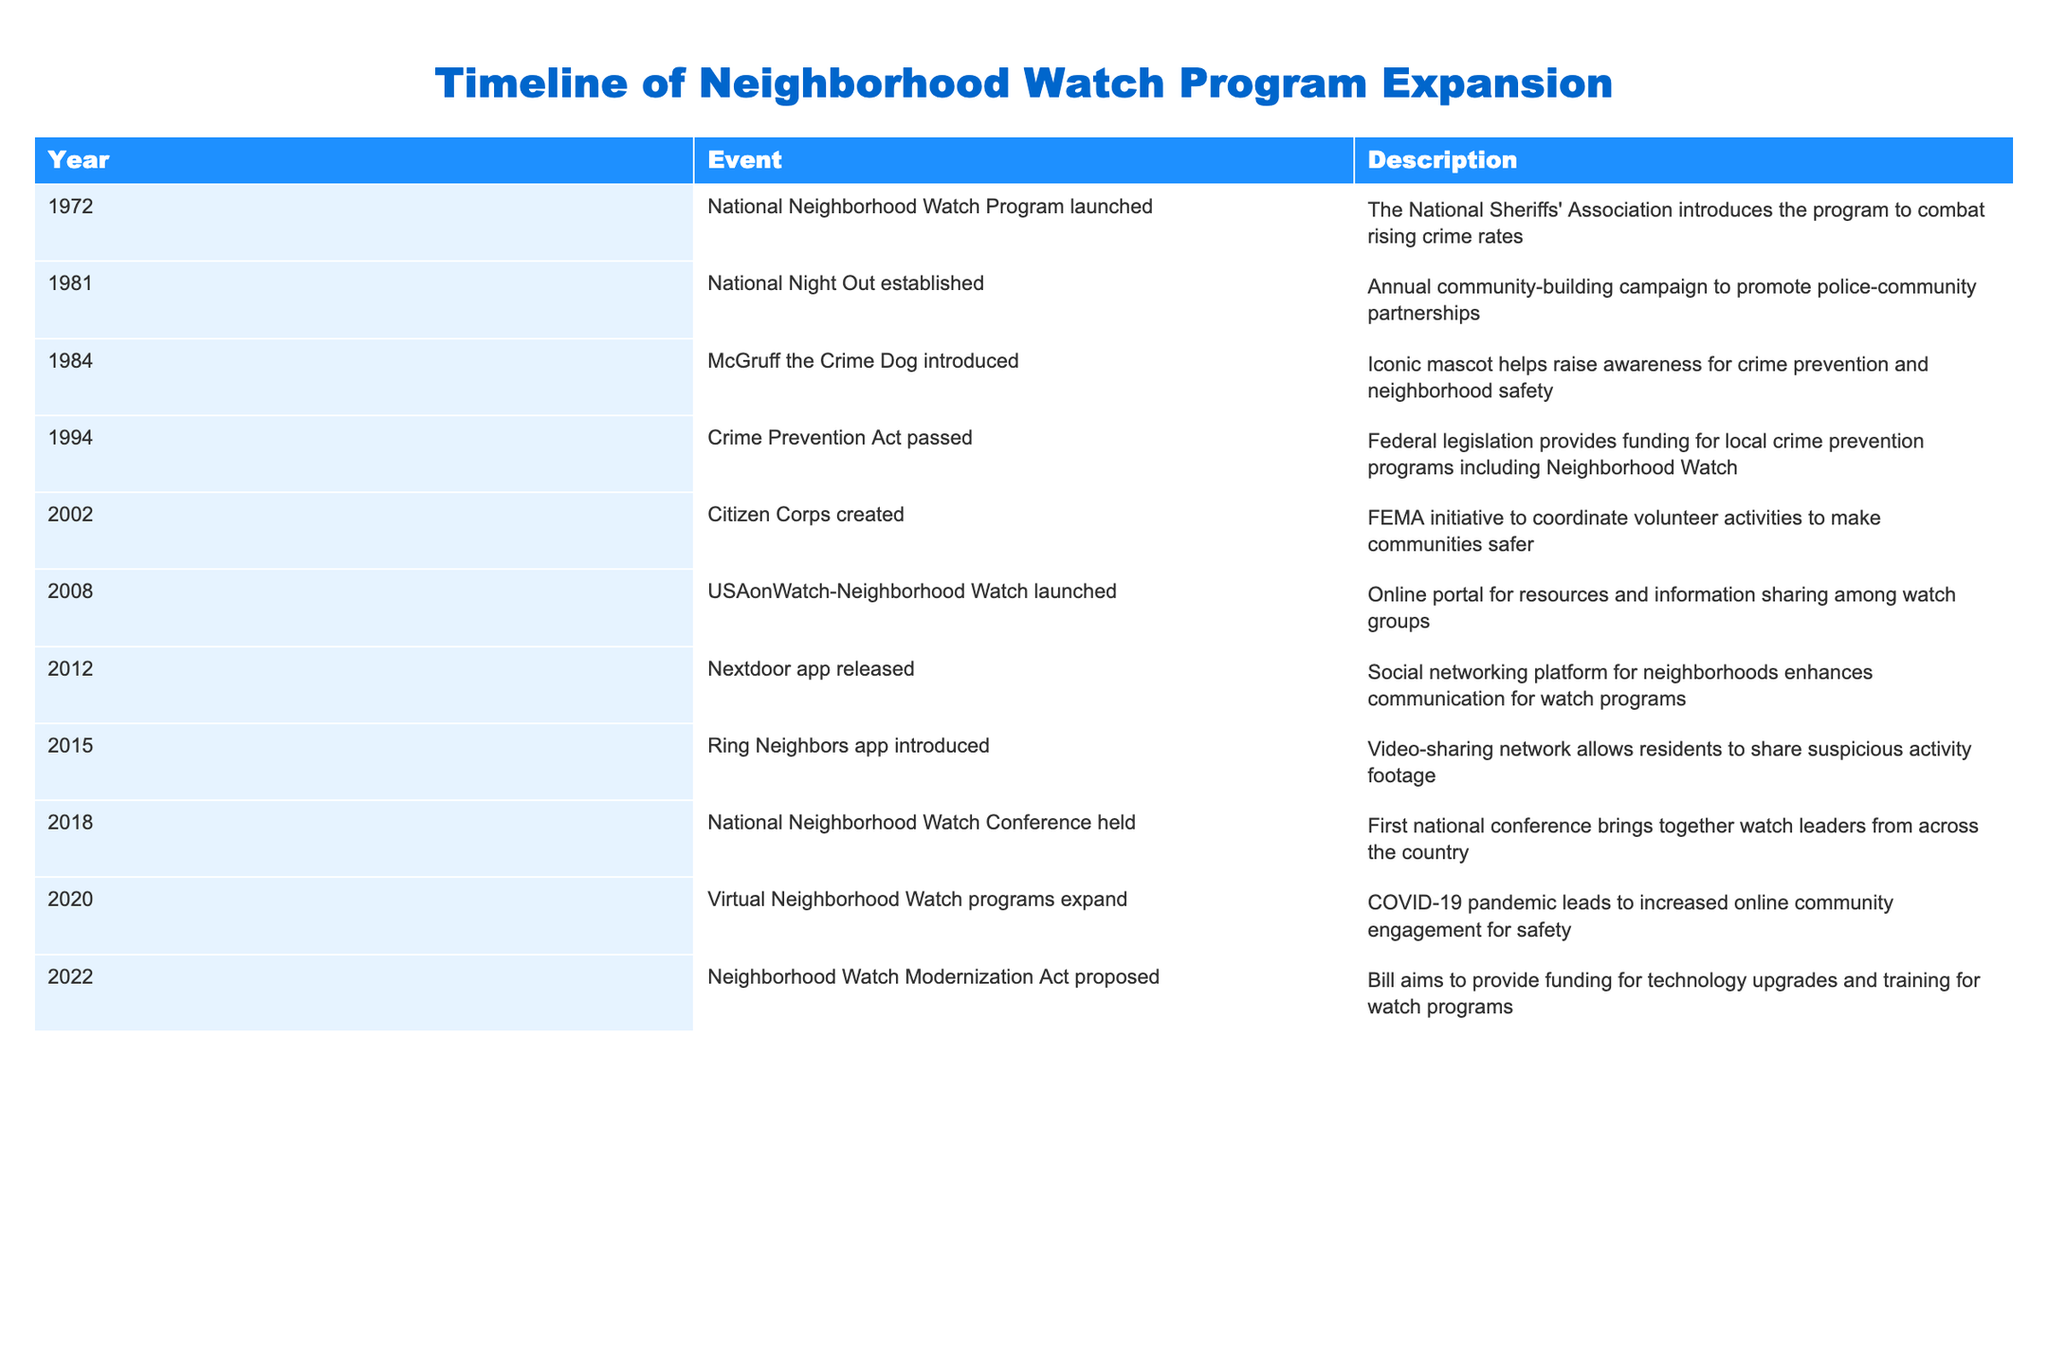What year was the National Neighborhood Watch Program launched? The table clearly states that the National Neighborhood Watch Program was launched in 1972.
Answer: 1972 What significant federal legislation was passed in 1994? The table indicates that the Crime Prevention Act was passed in 1994, providing funding for local crime prevention programs including Neighborhood Watch.
Answer: Crime Prevention Act How many events occurred between 2000 and 2020? By counting the entries from 2002 to 2020 inclusive, we find that there are 6 events listed in that timeframe: Citizen Corps created (2002), USAonWatch-Neighborhood Watch launched (2008), Nextdoor app released (2012), Ring Neighbors app introduced (2015), National Neighborhood Watch Conference held (2018), and Virtual Neighborhood Watch programs expand (2020).
Answer: 6 events Was the introduction of McGruff the Crime Dog before the establishment of the National Night Out? The table shows that McGruff the Crime Dog was introduced in 1984 and the National Night Out was established in 1981, confirming that the latter occurred first.
Answer: Yes Determine the number of years between the launching of the Citizen Corps in 2002 and the proposal of the Neighborhood Watch Modernization Act in 2022. Subtracting the year of the Citizen Corps creation (2002) from the year when the Neighborhood Watch Modernization Act was proposed (2022) gives us a difference of 20 years.
Answer: 20 years What is the latest event recorded in the timeline? The last event listed in the table is the proposal of the Neighborhood Watch Modernization Act in 2022, indicating that it is the most recent development.
Answer: Neighborhood Watch Modernization Act proposed Which event aimed at enhancing communication for watch programs was released in 2012? The table specifies that the Nextdoor app was released in 2012, dedicated to improving communication within neighborhoods for watch programs.
Answer: Nextdoor app released In how many years was the Crime Prevention Act passed since the launch of the National Neighborhood Watch Program? The Crime Prevention Act was passed in 1994, and the National Neighborhood Watch Program launched in 1972. Calculating 1994 - 1972 gives us 22 years.
Answer: 22 years Which two events in the table are related to technology enhancements for neighborhood safety? The two events that relate to technology are the release of the Nextdoor app in 2012 and the introduction of the Ring Neighbors app in 2015, both designed to enhance community safety through technology.
Answer: Nextdoor app and Ring Neighbors app 